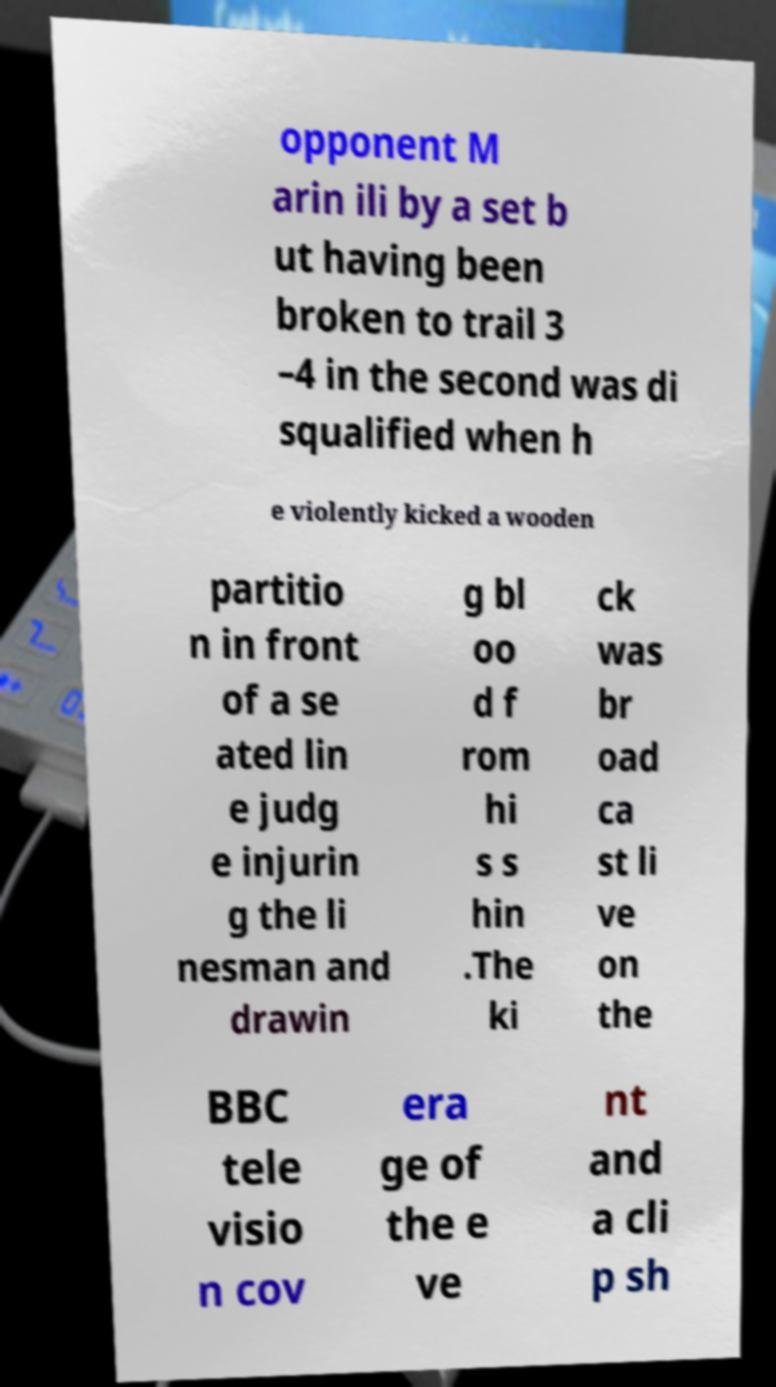I need the written content from this picture converted into text. Can you do that? opponent M arin ili by a set b ut having been broken to trail 3 –4 in the second was di squalified when h e violently kicked a wooden partitio n in front of a se ated lin e judg e injurin g the li nesman and drawin g bl oo d f rom hi s s hin .The ki ck was br oad ca st li ve on the BBC tele visio n cov era ge of the e ve nt and a cli p sh 